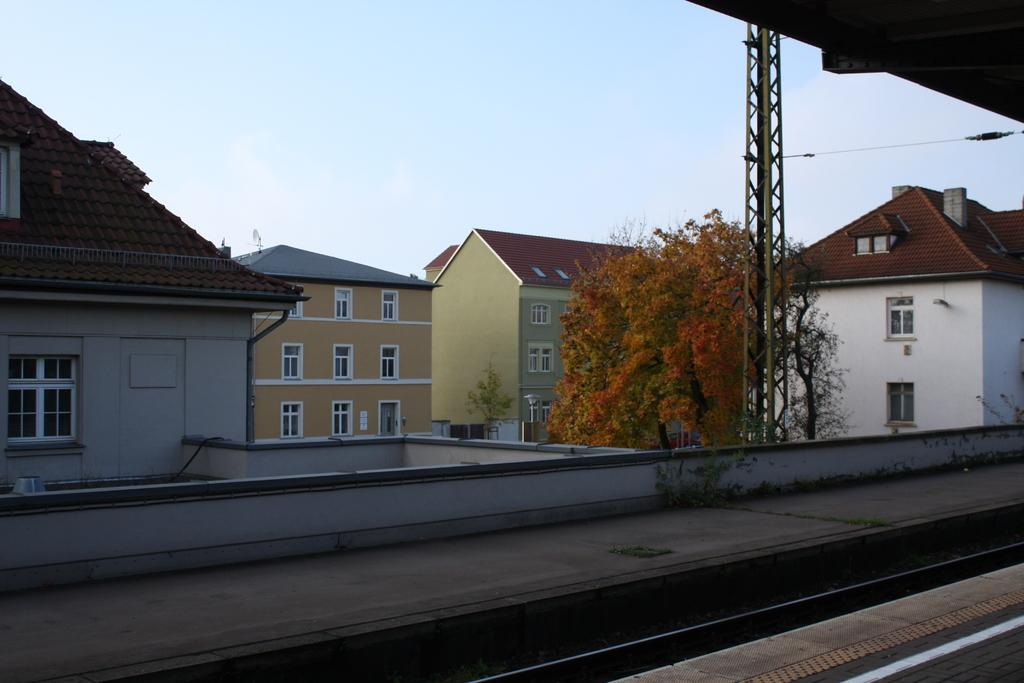What is the main feature in the foreground of the image? There is a train track in the image. What can be seen in the background of the image? There are buildings behind the train track. Is there any vegetation present in the image? Yes, there is a tree in the middle of the buildings. What is visible above the scene in the image? The sky is visible above the scene. How many fingers can be seen helping the tree grow in the image? There are no fingers or any indication of someone helping the tree grow in the image. 